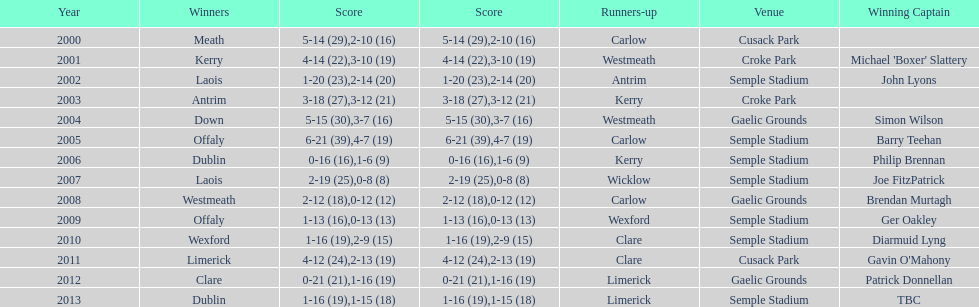Who was the victorious captain during the previous competition at the gaelic grounds venue? Patrick Donnellan. 